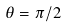<formula> <loc_0><loc_0><loc_500><loc_500>\theta = \pi / 2</formula> 